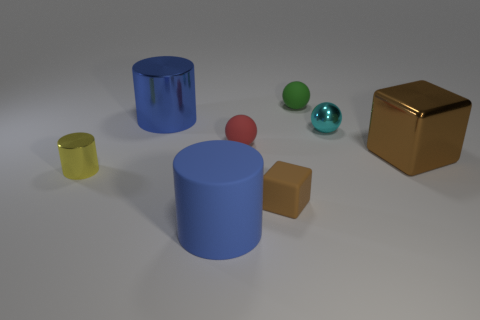Add 1 yellow spheres. How many objects exist? 9 Subtract all spheres. How many objects are left? 5 Subtract 0 gray cylinders. How many objects are left? 8 Subtract all green objects. Subtract all cyan spheres. How many objects are left? 6 Add 3 blue metal cylinders. How many blue metal cylinders are left? 4 Add 1 small green metal blocks. How many small green metal blocks exist? 1 